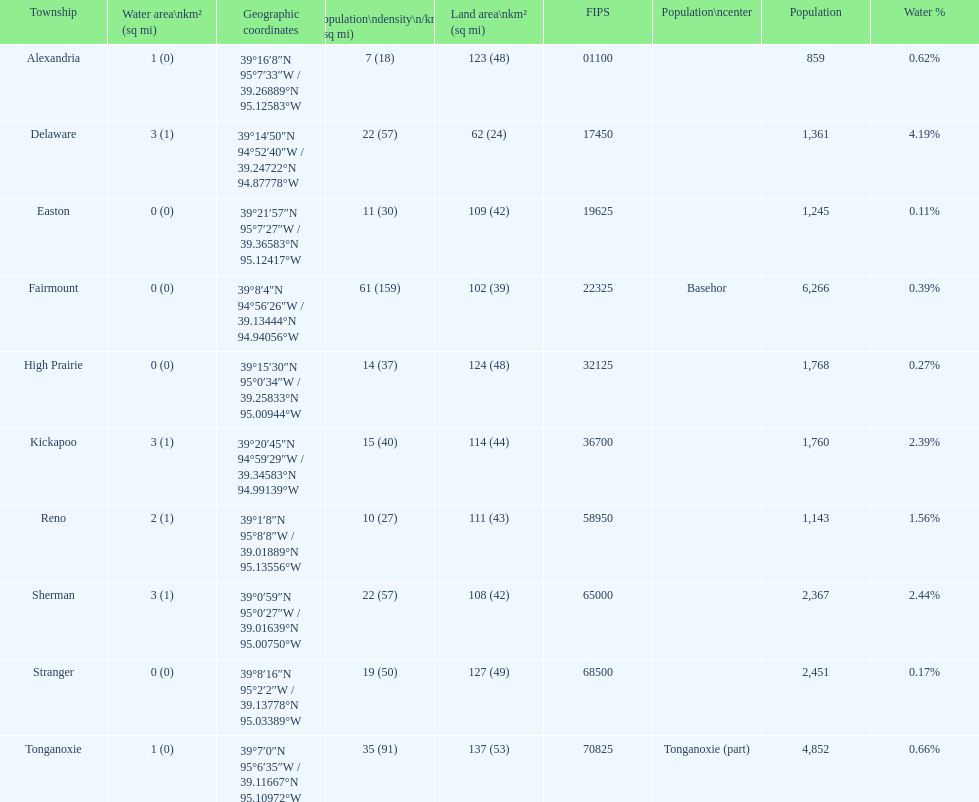How many townships have populations over 2,000? 4. 